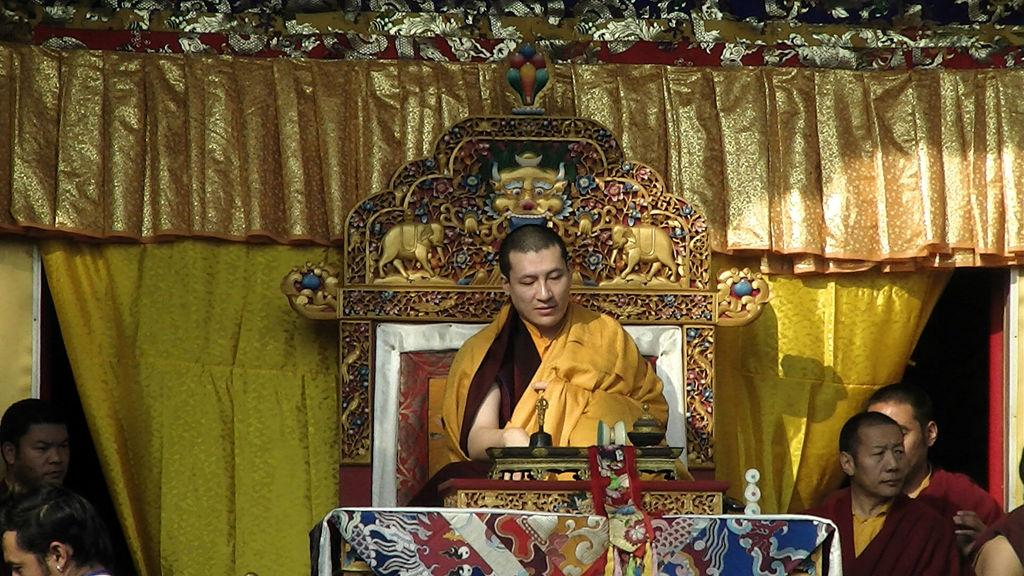What is the man in the image doing? The man is sitting on a chair in the image. Can you describe the people at the bottom of the image? There is a group of people standing at the bottom of the image. What type of fang can be seen in the man's mouth in the image? There is no fang visible in the man's mouth in the image. What kind of bread is being baked by the people at the bottom of the image? There is no bread or baking activity depicted in the image; it only shows a group of people standing. 